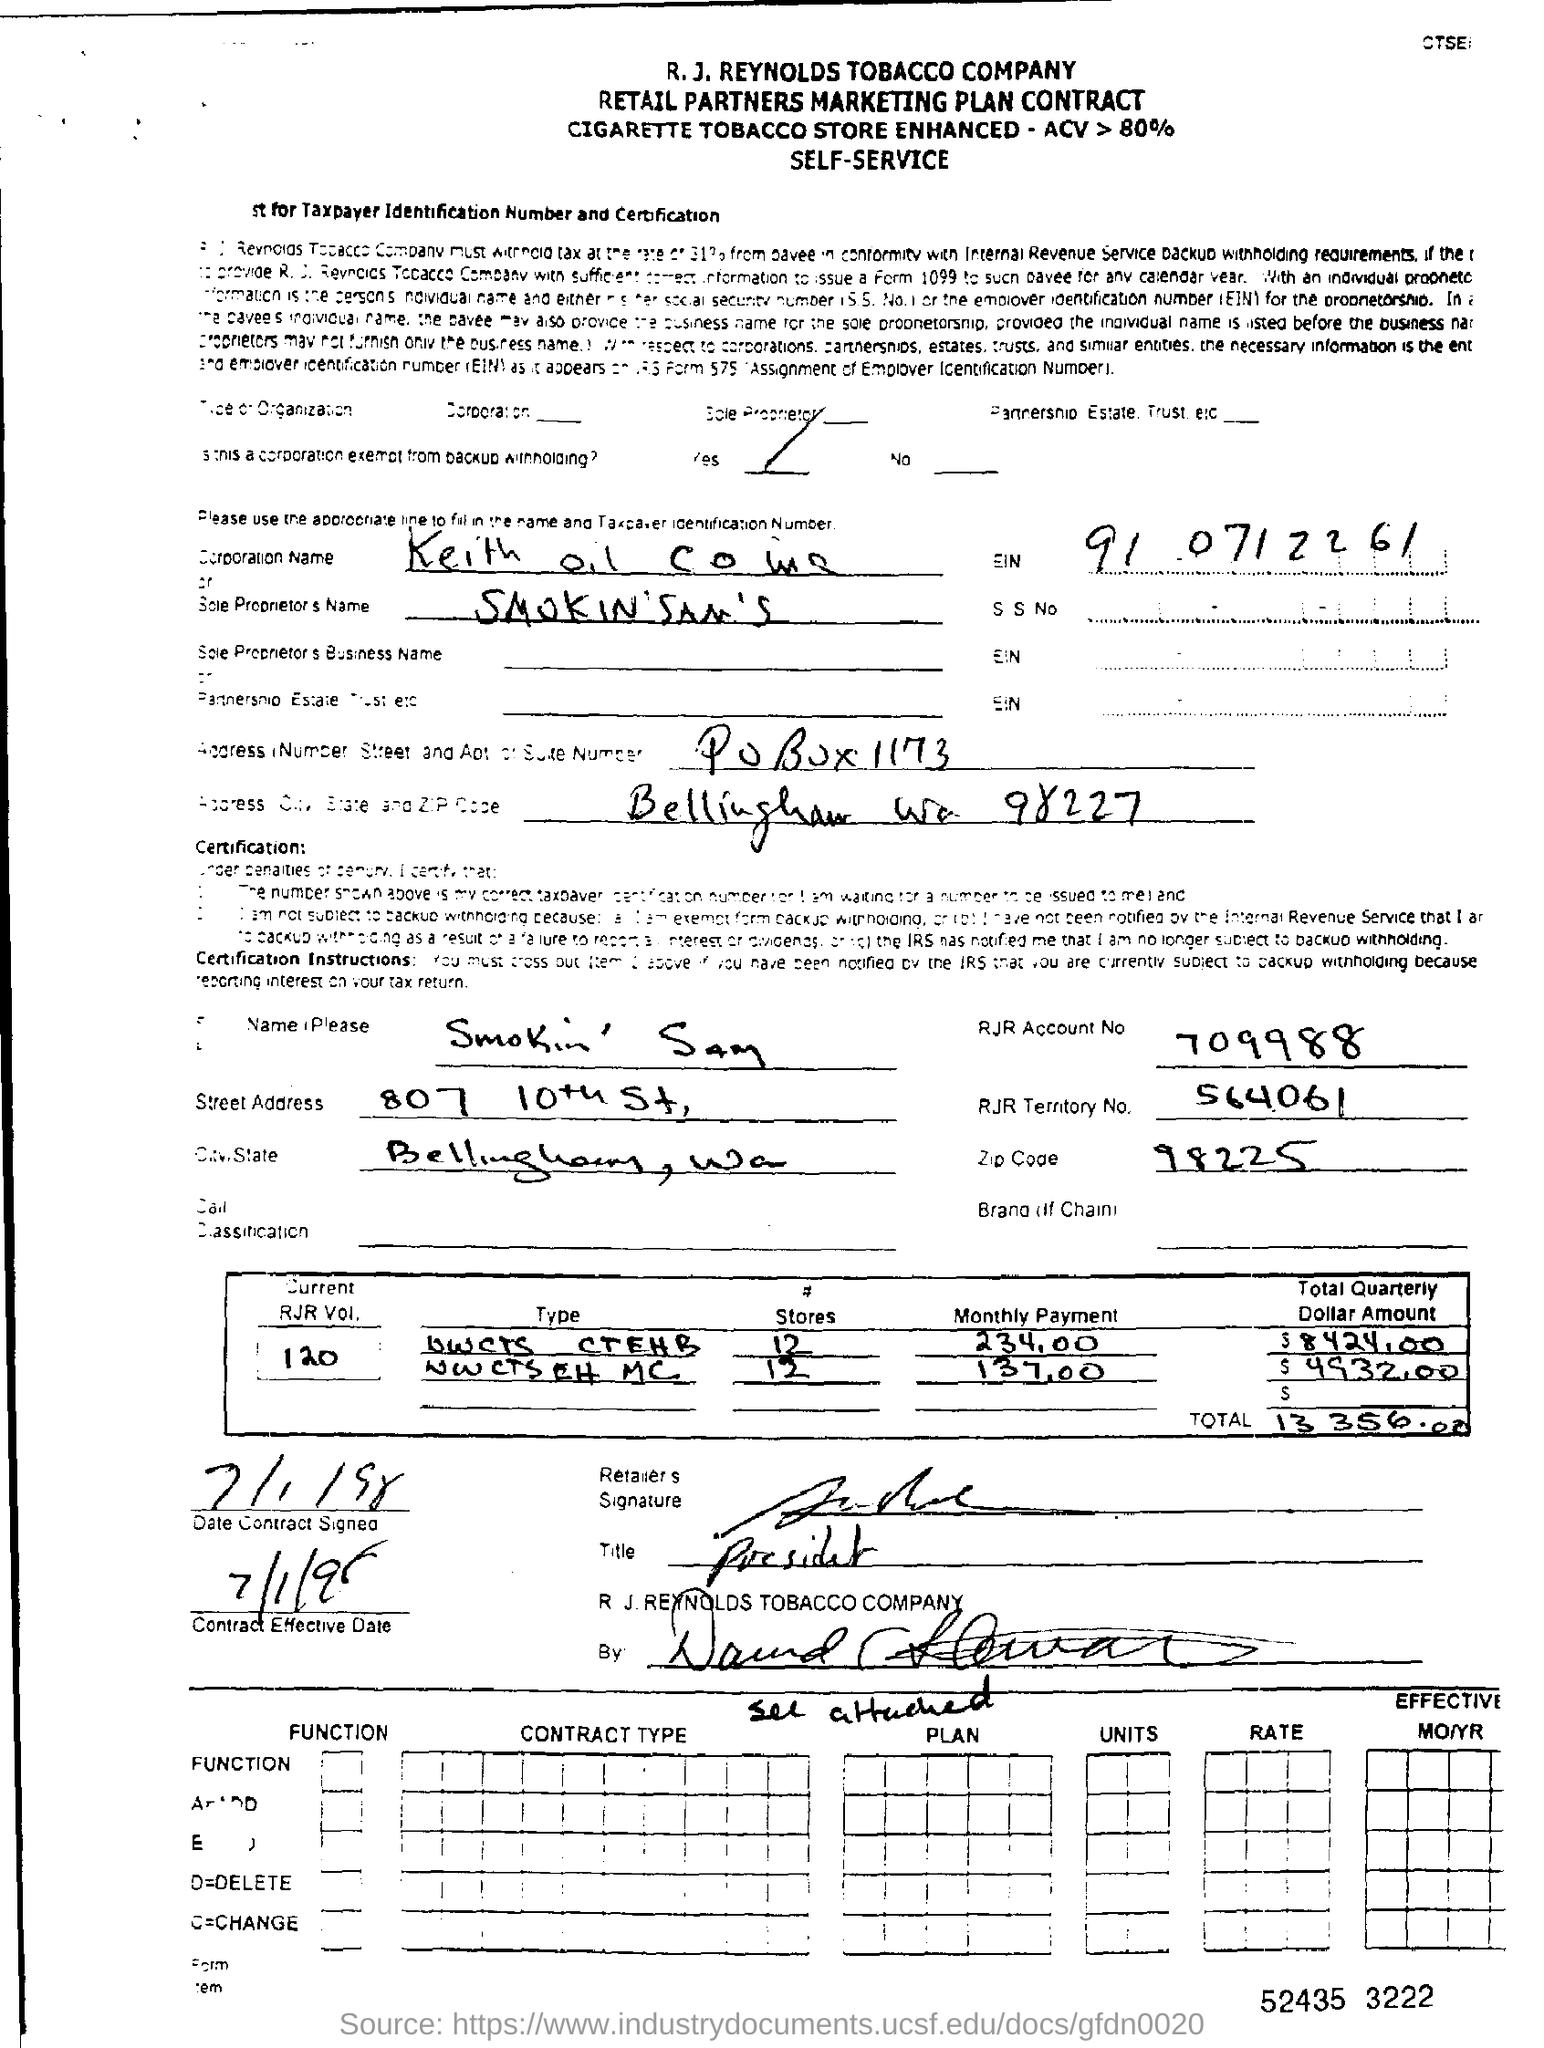Can you describe the type of document shown in the image? Certainly! The image displays a Retail Partners Marketing Plan Contract for a cigarette tobacco store, indicating a partnership with the R. J. Reynolds Tobacco Company. It outlines key details like the account number, the street address, and contractual amounts involving cigarette volume and associated payments.  What details can you provide about the entity involved in this contract? The contract appears to be with an entity named 'Smokin' Sam's', located at 807 10th Street, Bellingham, WA, with an RJR Territory No. S64061. This entity presumably operates one or more tobacco retail locations and has agreed to the terms set out in this marketing plan contract. 